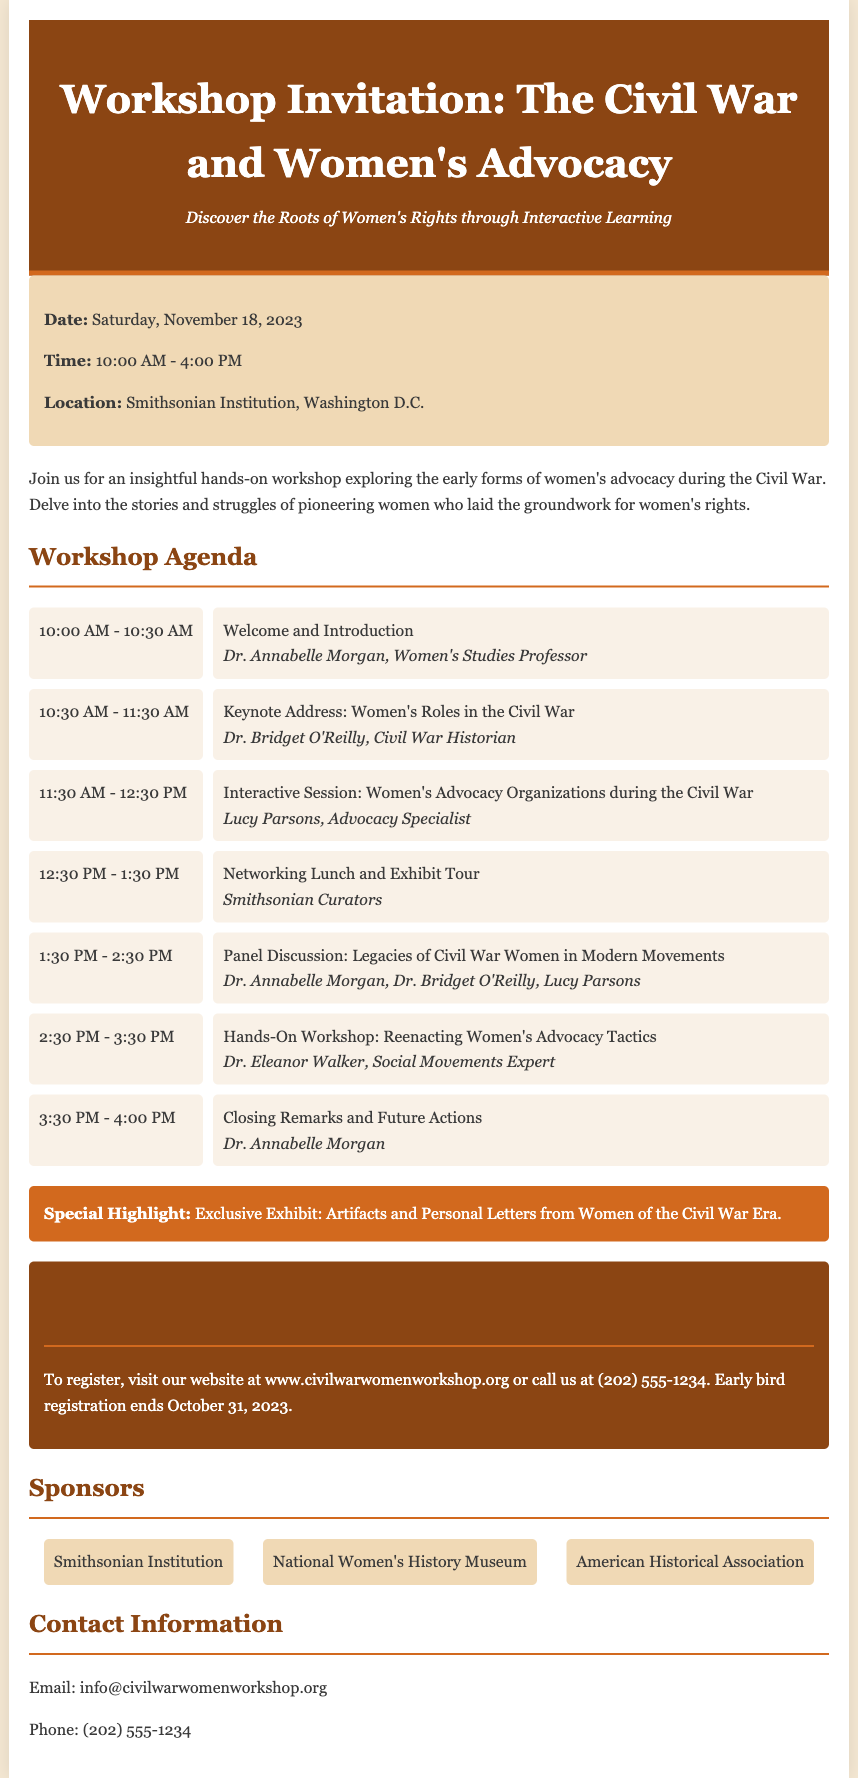What is the date of the workshop? The date of the workshop is explicitly mentioned in the document as Saturday, November 18, 2023.
Answer: Saturday, November 18, 2023 Who is the keynote speaker? The document specifies that Dr. Bridget O'Reilly is the keynote speaker for the workshop.
Answer: Dr. Bridget O'Reilly What time does the workshop start? The workshop start time is stated in the document as 10:00 AM.
Answer: 10:00 AM Which organization is hosting the event? The document identifies the Smithsonian Institution as the location and implied host of the workshop.
Answer: Smithsonian Institution What is a special highlight of the workshop? The document mentions an exclusive exhibit featuring artifacts and personal letters as a highlight.
Answer: Exclusive Exhibit: Artifacts and Personal Letters from Women of the Civil War Era What activity will take place at 1:30 PM? The agenda indicates that there will be a panel discussion at 1:30 PM.
Answer: Panel Discussion: Legacies of Civil War Women in Modern Movements When does early bird registration end? The document notes that early bird registration ends on October 31, 2023.
Answer: October 31, 2023 What type of workshop format is being offered? The document describes the workshop as a hands-on and interactive learning experience.
Answer: Hands-on workshop Which contact email is provided for inquiries? The document includes an email for contact as info@civilwarwomenworkshop.org.
Answer: info@civilwarwomenworkshop.org 